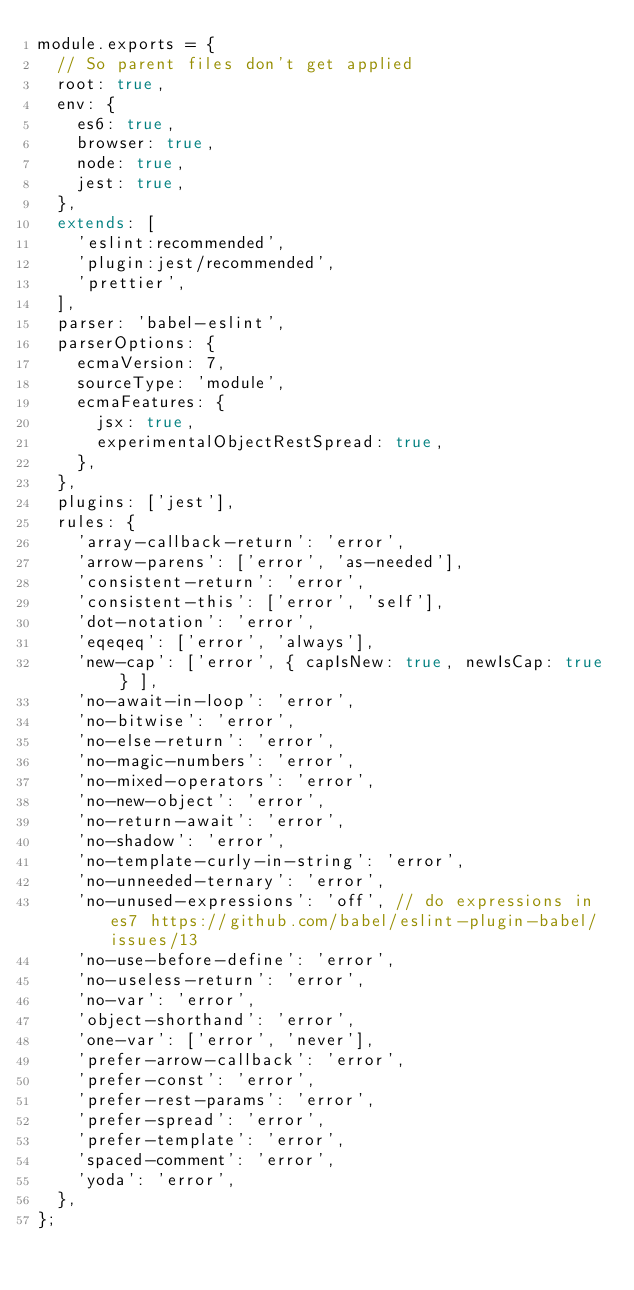<code> <loc_0><loc_0><loc_500><loc_500><_JavaScript_>module.exports = {
  // So parent files don't get applied
  root: true,
  env: {
    es6: true,
    browser: true,
    node: true,
    jest: true,
  },
  extends: [
    'eslint:recommended',
    'plugin:jest/recommended',
    'prettier',
  ],
  parser: 'babel-eslint',
  parserOptions: {
    ecmaVersion: 7,
    sourceType: 'module',
    ecmaFeatures: {
      jsx: true,
      experimentalObjectRestSpread: true,
    },
  },
  plugins: ['jest'],
  rules: {
    'array-callback-return': 'error',
    'arrow-parens': ['error', 'as-needed'],
    'consistent-return': 'error',
    'consistent-this': ['error', 'self'],
    'dot-notation': 'error',
    'eqeqeq': ['error', 'always'],
    'new-cap': ['error', { capIsNew: true, newIsCap: true } ],
    'no-await-in-loop': 'error',
    'no-bitwise': 'error',
    'no-else-return': 'error',
    'no-magic-numbers': 'error',
    'no-mixed-operators': 'error',
    'no-new-object': 'error',
    'no-return-await': 'error',
    'no-shadow': 'error',
    'no-template-curly-in-string': 'error',
    'no-unneeded-ternary': 'error',
    'no-unused-expressions': 'off', // do expressions in es7 https://github.com/babel/eslint-plugin-babel/issues/13
    'no-use-before-define': 'error',
    'no-useless-return': 'error',
    'no-var': 'error',
    'object-shorthand': 'error',
    'one-var': ['error', 'never'],
    'prefer-arrow-callback': 'error',
    'prefer-const': 'error',
    'prefer-rest-params': 'error',
    'prefer-spread': 'error',
    'prefer-template': 'error',
    'spaced-comment': 'error',
    'yoda': 'error',
  },
};
</code> 